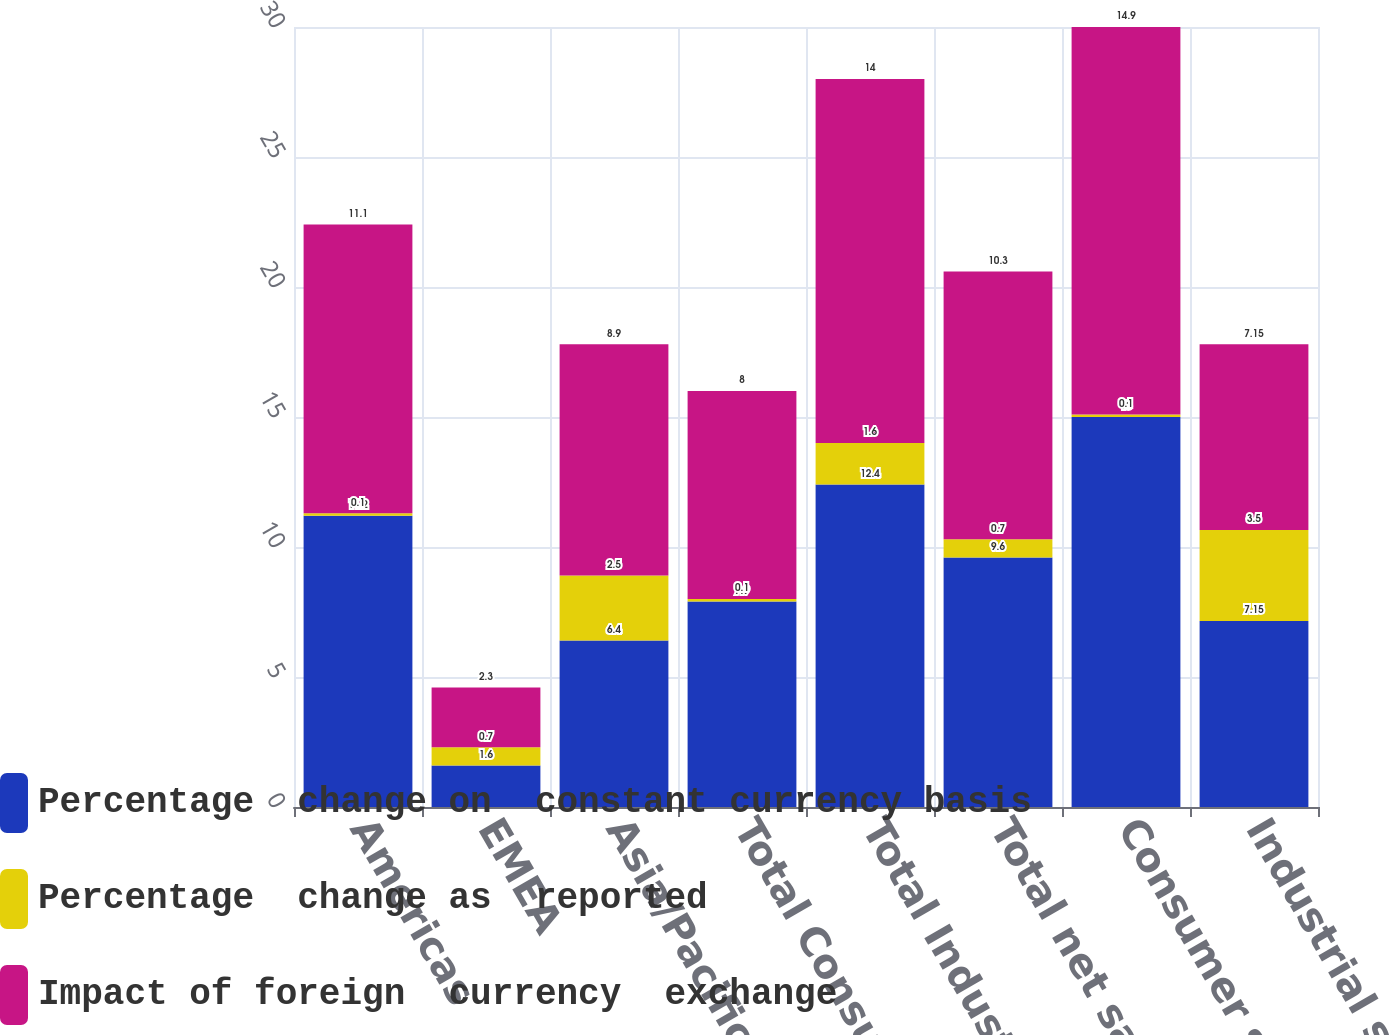Convert chart to OTSL. <chart><loc_0><loc_0><loc_500><loc_500><stacked_bar_chart><ecel><fcel>Americas<fcel>EMEA<fcel>Asia/Pacific<fcel>Total Consumer<fcel>Total Industrial<fcel>Total net sales<fcel>Consumer segment<fcel>Industrial segment<nl><fcel>Percentage  change on  constant currency basis<fcel>11.2<fcel>1.6<fcel>6.4<fcel>7.9<fcel>12.4<fcel>9.6<fcel>15<fcel>7.15<nl><fcel>Percentage  change as  reported<fcel>0.1<fcel>0.7<fcel>2.5<fcel>0.1<fcel>1.6<fcel>0.7<fcel>0.1<fcel>3.5<nl><fcel>Impact of foreign  currency  exchange<fcel>11.1<fcel>2.3<fcel>8.9<fcel>8<fcel>14<fcel>10.3<fcel>14.9<fcel>7.15<nl></chart> 